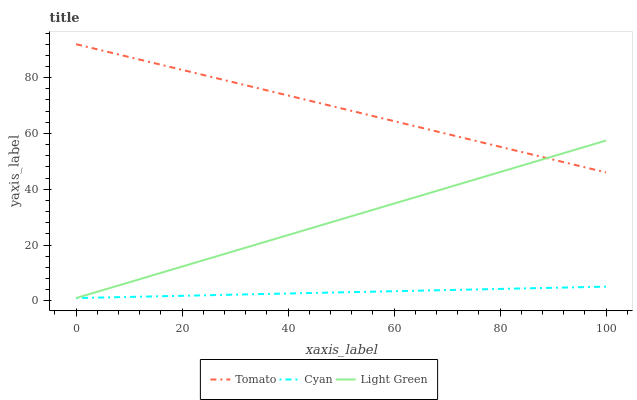Does Cyan have the minimum area under the curve?
Answer yes or no. Yes. Does Tomato have the maximum area under the curve?
Answer yes or no. Yes. Does Light Green have the minimum area under the curve?
Answer yes or no. No. Does Light Green have the maximum area under the curve?
Answer yes or no. No. Is Cyan the smoothest?
Answer yes or no. Yes. Is Tomato the roughest?
Answer yes or no. Yes. Is Light Green the smoothest?
Answer yes or no. No. Is Light Green the roughest?
Answer yes or no. No. Does Cyan have the lowest value?
Answer yes or no. Yes. Does Tomato have the highest value?
Answer yes or no. Yes. Does Light Green have the highest value?
Answer yes or no. No. Is Cyan less than Tomato?
Answer yes or no. Yes. Is Tomato greater than Cyan?
Answer yes or no. Yes. Does Cyan intersect Light Green?
Answer yes or no. Yes. Is Cyan less than Light Green?
Answer yes or no. No. Is Cyan greater than Light Green?
Answer yes or no. No. Does Cyan intersect Tomato?
Answer yes or no. No. 